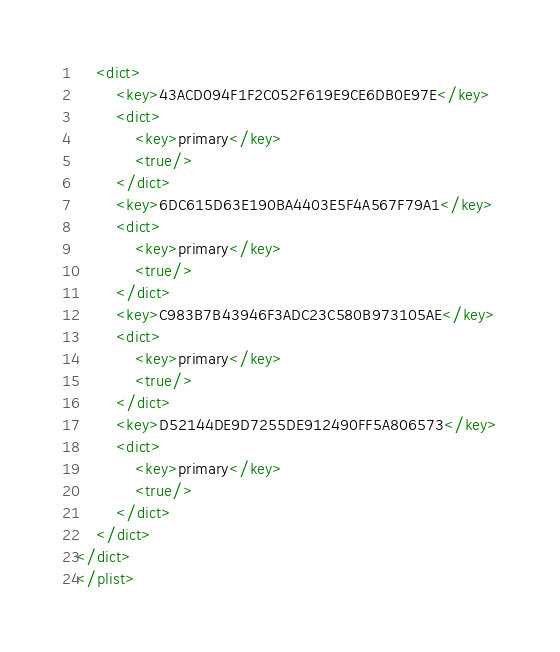<code> <loc_0><loc_0><loc_500><loc_500><_XML_>	<dict>
		<key>43ACD094F1F2C052F619E9CE6DB0E97E</key>
		<dict>
			<key>primary</key>
			<true/>
		</dict>
		<key>6DC615D63E190BA4403E5F4A567F79A1</key>
		<dict>
			<key>primary</key>
			<true/>
		</dict>
		<key>C983B7B43946F3ADC23C580B973105AE</key>
		<dict>
			<key>primary</key>
			<true/>
		</dict>
		<key>D52144DE9D7255DE912490FF5A806573</key>
		<dict>
			<key>primary</key>
			<true/>
		</dict>
	</dict>
</dict>
</plist>
</code> 